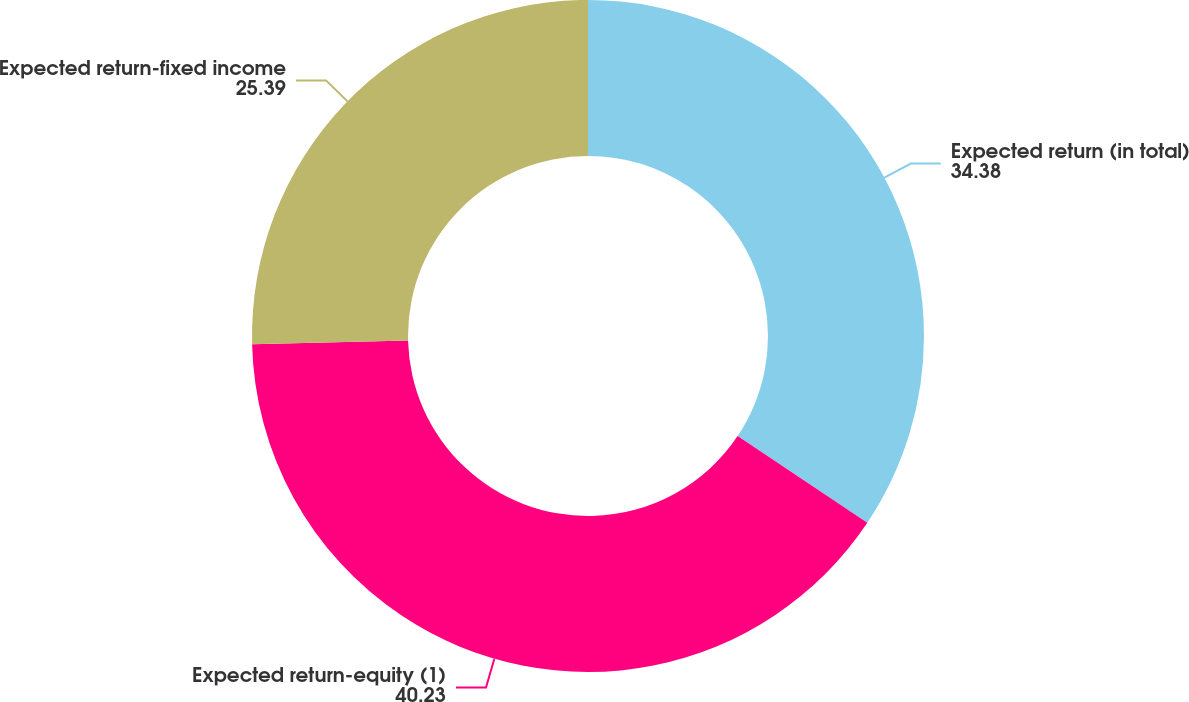<chart> <loc_0><loc_0><loc_500><loc_500><pie_chart><fcel>Expected return (in total)<fcel>Expected return-equity (1)<fcel>Expected return-fixed income<nl><fcel>34.38%<fcel>40.23%<fcel>25.39%<nl></chart> 